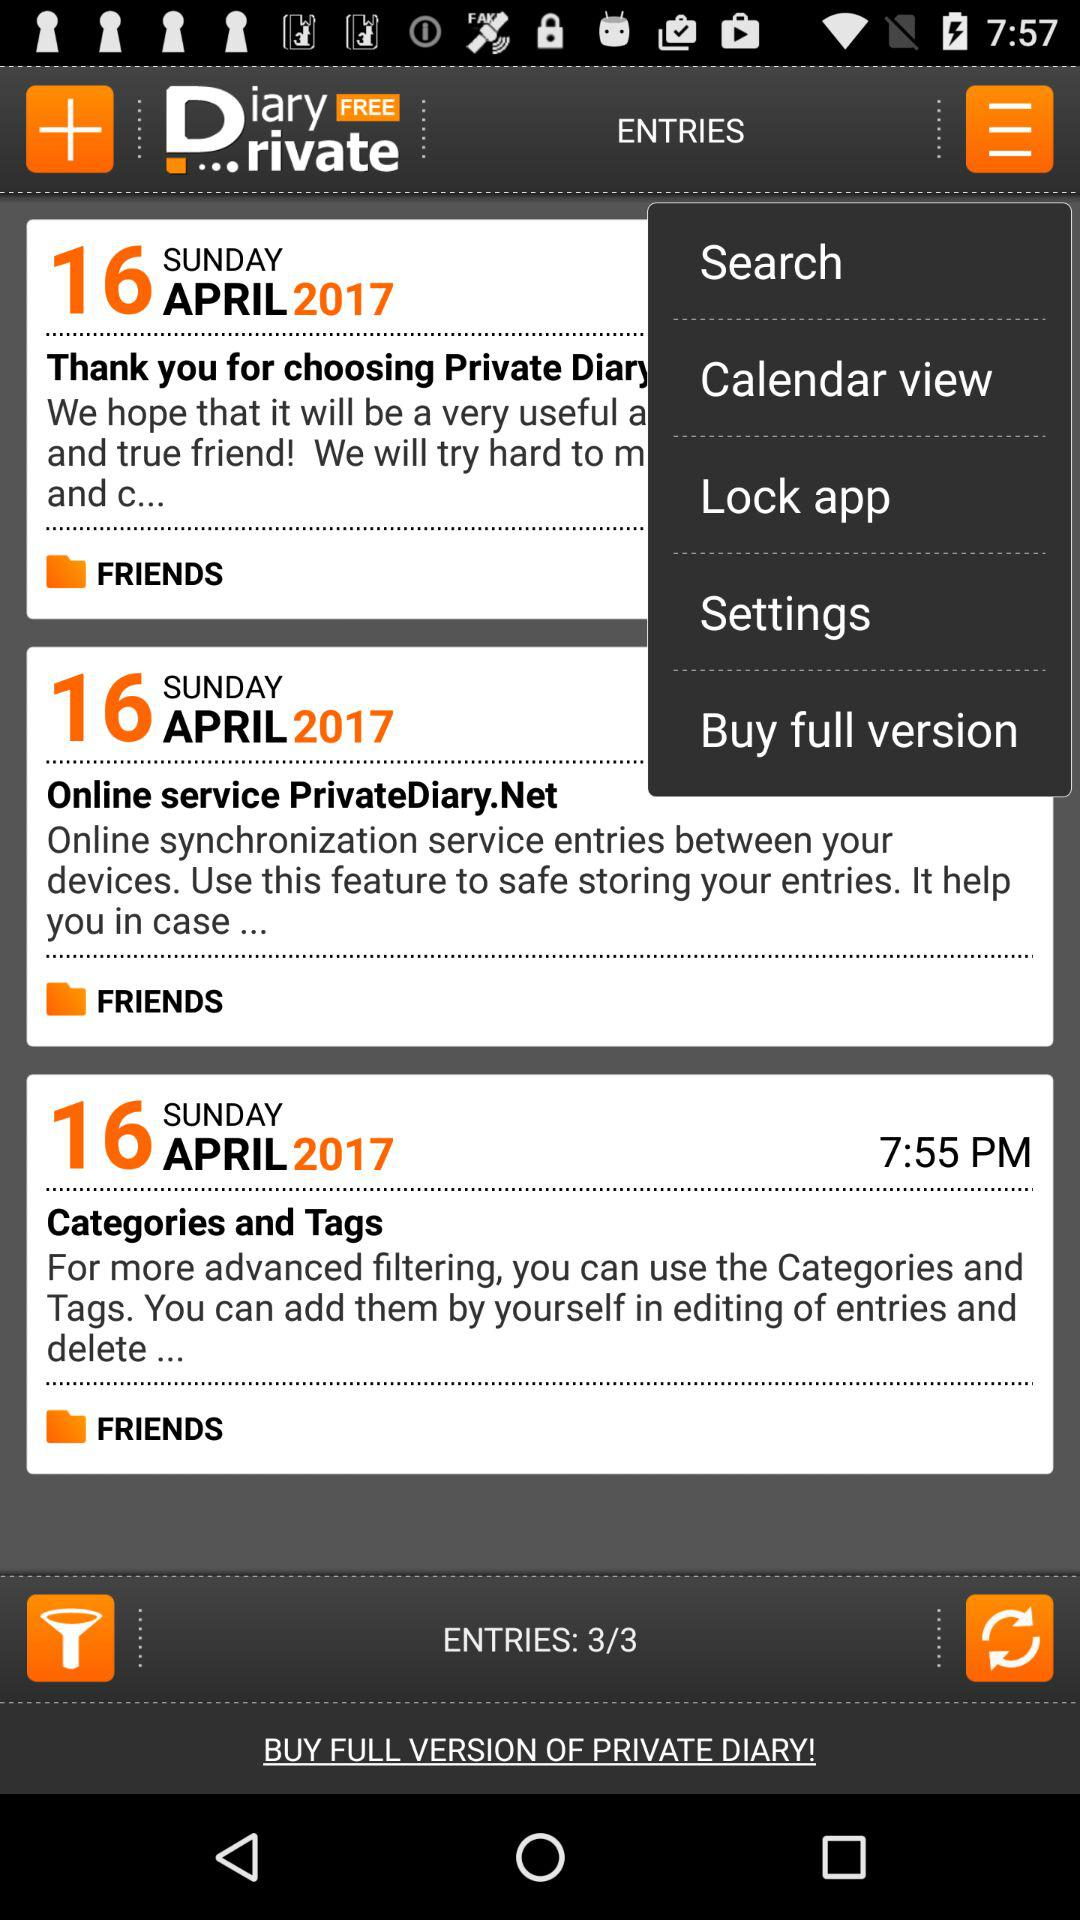On which page is the person currently?
When the provided information is insufficient, respond with <no answer>. <no answer> 